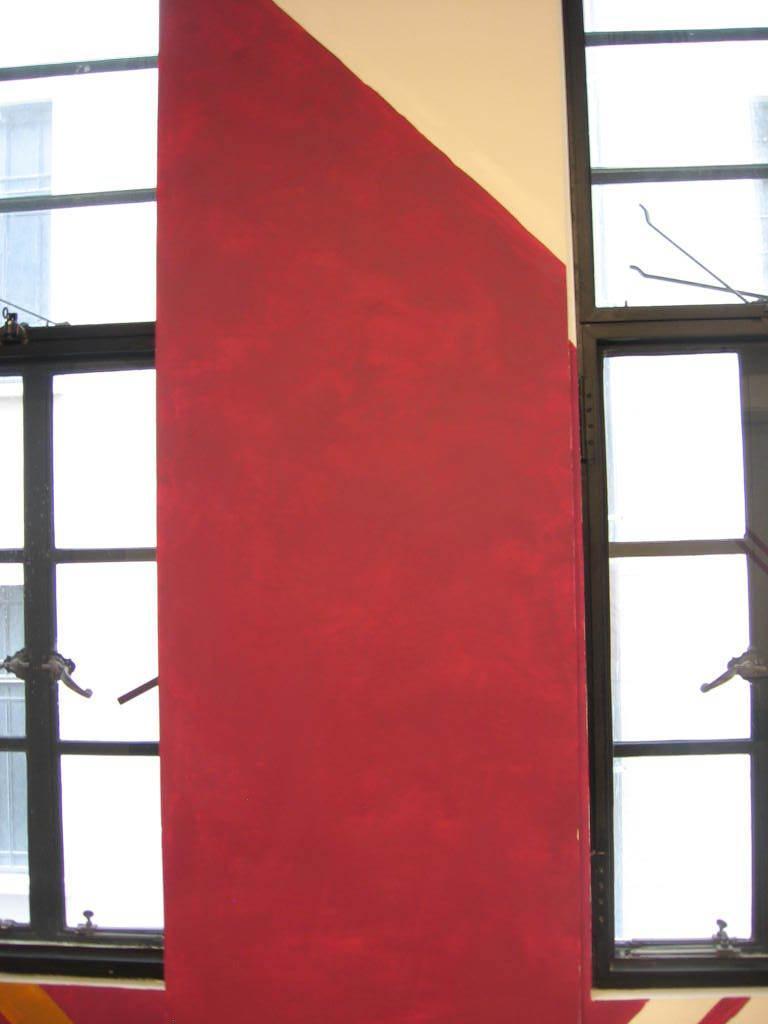Describe this image in one or two sentences. In this image we can see there is a wall in middle of this image and there is a window on the left side of this image and on the right side of this image as well. 